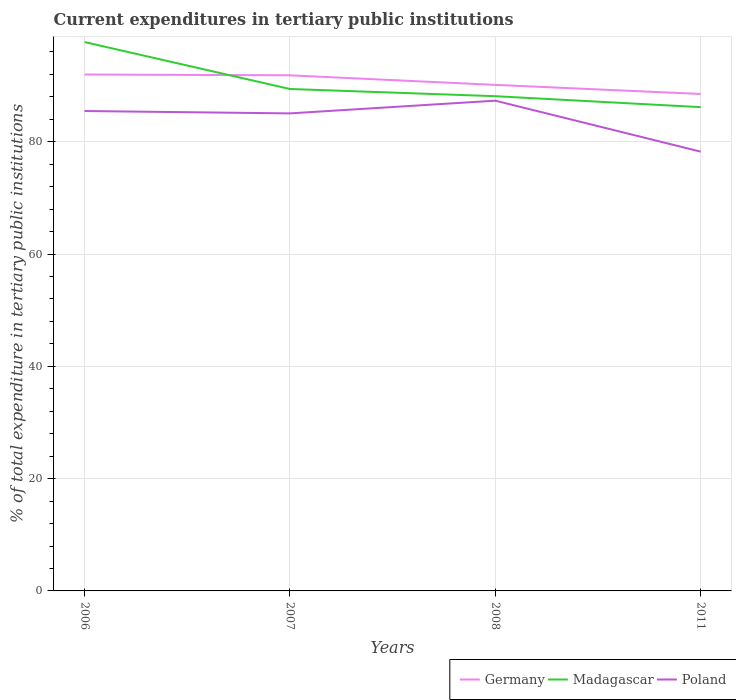How many different coloured lines are there?
Keep it short and to the point. 3. Does the line corresponding to Madagascar intersect with the line corresponding to Germany?
Offer a terse response. Yes. Is the number of lines equal to the number of legend labels?
Provide a short and direct response. Yes. Across all years, what is the maximum current expenditures in tertiary public institutions in Poland?
Your answer should be very brief. 78.23. In which year was the current expenditures in tertiary public institutions in Germany maximum?
Offer a terse response. 2011. What is the total current expenditures in tertiary public institutions in Poland in the graph?
Give a very brief answer. 7.24. What is the difference between the highest and the second highest current expenditures in tertiary public institutions in Madagascar?
Your answer should be compact. 11.59. What is the difference between the highest and the lowest current expenditures in tertiary public institutions in Poland?
Your answer should be very brief. 3. Are the values on the major ticks of Y-axis written in scientific E-notation?
Your answer should be compact. No. How many legend labels are there?
Provide a short and direct response. 3. How are the legend labels stacked?
Your answer should be very brief. Horizontal. What is the title of the graph?
Keep it short and to the point. Current expenditures in tertiary public institutions. What is the label or title of the Y-axis?
Keep it short and to the point. % of total expenditure in tertiary public institutions. What is the % of total expenditure in tertiary public institutions in Germany in 2006?
Make the answer very short. 91.97. What is the % of total expenditure in tertiary public institutions of Madagascar in 2006?
Give a very brief answer. 97.75. What is the % of total expenditure in tertiary public institutions in Poland in 2006?
Keep it short and to the point. 85.47. What is the % of total expenditure in tertiary public institutions in Germany in 2007?
Your response must be concise. 91.83. What is the % of total expenditure in tertiary public institutions of Madagascar in 2007?
Provide a succinct answer. 89.39. What is the % of total expenditure in tertiary public institutions in Poland in 2007?
Offer a terse response. 85.05. What is the % of total expenditure in tertiary public institutions in Germany in 2008?
Make the answer very short. 90.12. What is the % of total expenditure in tertiary public institutions in Madagascar in 2008?
Ensure brevity in your answer.  88.11. What is the % of total expenditure in tertiary public institutions in Poland in 2008?
Provide a short and direct response. 87.31. What is the % of total expenditure in tertiary public institutions in Germany in 2011?
Your response must be concise. 88.5. What is the % of total expenditure in tertiary public institutions in Madagascar in 2011?
Make the answer very short. 86.16. What is the % of total expenditure in tertiary public institutions of Poland in 2011?
Give a very brief answer. 78.23. Across all years, what is the maximum % of total expenditure in tertiary public institutions in Germany?
Your answer should be compact. 91.97. Across all years, what is the maximum % of total expenditure in tertiary public institutions in Madagascar?
Provide a short and direct response. 97.75. Across all years, what is the maximum % of total expenditure in tertiary public institutions in Poland?
Your answer should be very brief. 87.31. Across all years, what is the minimum % of total expenditure in tertiary public institutions in Germany?
Offer a very short reply. 88.5. Across all years, what is the minimum % of total expenditure in tertiary public institutions in Madagascar?
Keep it short and to the point. 86.16. Across all years, what is the minimum % of total expenditure in tertiary public institutions of Poland?
Your answer should be compact. 78.23. What is the total % of total expenditure in tertiary public institutions in Germany in the graph?
Your answer should be compact. 362.42. What is the total % of total expenditure in tertiary public institutions of Madagascar in the graph?
Give a very brief answer. 361.41. What is the total % of total expenditure in tertiary public institutions of Poland in the graph?
Your response must be concise. 336.06. What is the difference between the % of total expenditure in tertiary public institutions of Germany in 2006 and that in 2007?
Ensure brevity in your answer.  0.15. What is the difference between the % of total expenditure in tertiary public institutions of Madagascar in 2006 and that in 2007?
Give a very brief answer. 8.36. What is the difference between the % of total expenditure in tertiary public institutions in Poland in 2006 and that in 2007?
Ensure brevity in your answer.  0.42. What is the difference between the % of total expenditure in tertiary public institutions of Germany in 2006 and that in 2008?
Offer a terse response. 1.85. What is the difference between the % of total expenditure in tertiary public institutions of Madagascar in 2006 and that in 2008?
Offer a very short reply. 9.64. What is the difference between the % of total expenditure in tertiary public institutions in Poland in 2006 and that in 2008?
Your response must be concise. -1.84. What is the difference between the % of total expenditure in tertiary public institutions of Germany in 2006 and that in 2011?
Make the answer very short. 3.47. What is the difference between the % of total expenditure in tertiary public institutions in Madagascar in 2006 and that in 2011?
Provide a short and direct response. 11.59. What is the difference between the % of total expenditure in tertiary public institutions of Poland in 2006 and that in 2011?
Provide a short and direct response. 7.24. What is the difference between the % of total expenditure in tertiary public institutions in Germany in 2007 and that in 2008?
Keep it short and to the point. 1.7. What is the difference between the % of total expenditure in tertiary public institutions of Madagascar in 2007 and that in 2008?
Give a very brief answer. 1.28. What is the difference between the % of total expenditure in tertiary public institutions in Poland in 2007 and that in 2008?
Provide a succinct answer. -2.26. What is the difference between the % of total expenditure in tertiary public institutions of Germany in 2007 and that in 2011?
Ensure brevity in your answer.  3.32. What is the difference between the % of total expenditure in tertiary public institutions of Madagascar in 2007 and that in 2011?
Your answer should be very brief. 3.23. What is the difference between the % of total expenditure in tertiary public institutions of Poland in 2007 and that in 2011?
Keep it short and to the point. 6.81. What is the difference between the % of total expenditure in tertiary public institutions of Germany in 2008 and that in 2011?
Provide a short and direct response. 1.62. What is the difference between the % of total expenditure in tertiary public institutions of Madagascar in 2008 and that in 2011?
Give a very brief answer. 1.95. What is the difference between the % of total expenditure in tertiary public institutions of Poland in 2008 and that in 2011?
Keep it short and to the point. 9.08. What is the difference between the % of total expenditure in tertiary public institutions in Germany in 2006 and the % of total expenditure in tertiary public institutions in Madagascar in 2007?
Make the answer very short. 2.58. What is the difference between the % of total expenditure in tertiary public institutions of Germany in 2006 and the % of total expenditure in tertiary public institutions of Poland in 2007?
Your response must be concise. 6.93. What is the difference between the % of total expenditure in tertiary public institutions in Madagascar in 2006 and the % of total expenditure in tertiary public institutions in Poland in 2007?
Your response must be concise. 12.7. What is the difference between the % of total expenditure in tertiary public institutions in Germany in 2006 and the % of total expenditure in tertiary public institutions in Madagascar in 2008?
Offer a terse response. 3.87. What is the difference between the % of total expenditure in tertiary public institutions of Germany in 2006 and the % of total expenditure in tertiary public institutions of Poland in 2008?
Ensure brevity in your answer.  4.66. What is the difference between the % of total expenditure in tertiary public institutions of Madagascar in 2006 and the % of total expenditure in tertiary public institutions of Poland in 2008?
Your response must be concise. 10.44. What is the difference between the % of total expenditure in tertiary public institutions in Germany in 2006 and the % of total expenditure in tertiary public institutions in Madagascar in 2011?
Offer a very short reply. 5.82. What is the difference between the % of total expenditure in tertiary public institutions in Germany in 2006 and the % of total expenditure in tertiary public institutions in Poland in 2011?
Provide a succinct answer. 13.74. What is the difference between the % of total expenditure in tertiary public institutions in Madagascar in 2006 and the % of total expenditure in tertiary public institutions in Poland in 2011?
Provide a succinct answer. 19.52. What is the difference between the % of total expenditure in tertiary public institutions in Germany in 2007 and the % of total expenditure in tertiary public institutions in Madagascar in 2008?
Make the answer very short. 3.72. What is the difference between the % of total expenditure in tertiary public institutions of Germany in 2007 and the % of total expenditure in tertiary public institutions of Poland in 2008?
Make the answer very short. 4.51. What is the difference between the % of total expenditure in tertiary public institutions in Madagascar in 2007 and the % of total expenditure in tertiary public institutions in Poland in 2008?
Keep it short and to the point. 2.08. What is the difference between the % of total expenditure in tertiary public institutions in Germany in 2007 and the % of total expenditure in tertiary public institutions in Madagascar in 2011?
Your response must be concise. 5.67. What is the difference between the % of total expenditure in tertiary public institutions in Germany in 2007 and the % of total expenditure in tertiary public institutions in Poland in 2011?
Offer a very short reply. 13.59. What is the difference between the % of total expenditure in tertiary public institutions of Madagascar in 2007 and the % of total expenditure in tertiary public institutions of Poland in 2011?
Provide a short and direct response. 11.16. What is the difference between the % of total expenditure in tertiary public institutions of Germany in 2008 and the % of total expenditure in tertiary public institutions of Madagascar in 2011?
Make the answer very short. 3.96. What is the difference between the % of total expenditure in tertiary public institutions of Germany in 2008 and the % of total expenditure in tertiary public institutions of Poland in 2011?
Offer a terse response. 11.89. What is the difference between the % of total expenditure in tertiary public institutions of Madagascar in 2008 and the % of total expenditure in tertiary public institutions of Poland in 2011?
Provide a short and direct response. 9.88. What is the average % of total expenditure in tertiary public institutions in Germany per year?
Make the answer very short. 90.61. What is the average % of total expenditure in tertiary public institutions in Madagascar per year?
Offer a terse response. 90.35. What is the average % of total expenditure in tertiary public institutions of Poland per year?
Your response must be concise. 84.01. In the year 2006, what is the difference between the % of total expenditure in tertiary public institutions in Germany and % of total expenditure in tertiary public institutions in Madagascar?
Keep it short and to the point. -5.78. In the year 2006, what is the difference between the % of total expenditure in tertiary public institutions of Germany and % of total expenditure in tertiary public institutions of Poland?
Your answer should be very brief. 6.5. In the year 2006, what is the difference between the % of total expenditure in tertiary public institutions in Madagascar and % of total expenditure in tertiary public institutions in Poland?
Make the answer very short. 12.28. In the year 2007, what is the difference between the % of total expenditure in tertiary public institutions in Germany and % of total expenditure in tertiary public institutions in Madagascar?
Offer a very short reply. 2.43. In the year 2007, what is the difference between the % of total expenditure in tertiary public institutions in Germany and % of total expenditure in tertiary public institutions in Poland?
Offer a very short reply. 6.78. In the year 2007, what is the difference between the % of total expenditure in tertiary public institutions of Madagascar and % of total expenditure in tertiary public institutions of Poland?
Make the answer very short. 4.34. In the year 2008, what is the difference between the % of total expenditure in tertiary public institutions in Germany and % of total expenditure in tertiary public institutions in Madagascar?
Your answer should be very brief. 2.01. In the year 2008, what is the difference between the % of total expenditure in tertiary public institutions of Germany and % of total expenditure in tertiary public institutions of Poland?
Your response must be concise. 2.81. In the year 2008, what is the difference between the % of total expenditure in tertiary public institutions of Madagascar and % of total expenditure in tertiary public institutions of Poland?
Your answer should be compact. 0.8. In the year 2011, what is the difference between the % of total expenditure in tertiary public institutions of Germany and % of total expenditure in tertiary public institutions of Madagascar?
Provide a short and direct response. 2.35. In the year 2011, what is the difference between the % of total expenditure in tertiary public institutions in Germany and % of total expenditure in tertiary public institutions in Poland?
Give a very brief answer. 10.27. In the year 2011, what is the difference between the % of total expenditure in tertiary public institutions of Madagascar and % of total expenditure in tertiary public institutions of Poland?
Offer a terse response. 7.93. What is the ratio of the % of total expenditure in tertiary public institutions of Madagascar in 2006 to that in 2007?
Provide a succinct answer. 1.09. What is the ratio of the % of total expenditure in tertiary public institutions of Poland in 2006 to that in 2007?
Your answer should be very brief. 1. What is the ratio of the % of total expenditure in tertiary public institutions in Germany in 2006 to that in 2008?
Your answer should be very brief. 1.02. What is the ratio of the % of total expenditure in tertiary public institutions in Madagascar in 2006 to that in 2008?
Ensure brevity in your answer.  1.11. What is the ratio of the % of total expenditure in tertiary public institutions of Poland in 2006 to that in 2008?
Your answer should be very brief. 0.98. What is the ratio of the % of total expenditure in tertiary public institutions of Germany in 2006 to that in 2011?
Provide a succinct answer. 1.04. What is the ratio of the % of total expenditure in tertiary public institutions in Madagascar in 2006 to that in 2011?
Offer a terse response. 1.13. What is the ratio of the % of total expenditure in tertiary public institutions of Poland in 2006 to that in 2011?
Offer a very short reply. 1.09. What is the ratio of the % of total expenditure in tertiary public institutions in Germany in 2007 to that in 2008?
Give a very brief answer. 1.02. What is the ratio of the % of total expenditure in tertiary public institutions in Madagascar in 2007 to that in 2008?
Your answer should be very brief. 1.01. What is the ratio of the % of total expenditure in tertiary public institutions of Poland in 2007 to that in 2008?
Your response must be concise. 0.97. What is the ratio of the % of total expenditure in tertiary public institutions in Germany in 2007 to that in 2011?
Make the answer very short. 1.04. What is the ratio of the % of total expenditure in tertiary public institutions in Madagascar in 2007 to that in 2011?
Your answer should be compact. 1.04. What is the ratio of the % of total expenditure in tertiary public institutions in Poland in 2007 to that in 2011?
Your answer should be compact. 1.09. What is the ratio of the % of total expenditure in tertiary public institutions in Germany in 2008 to that in 2011?
Make the answer very short. 1.02. What is the ratio of the % of total expenditure in tertiary public institutions in Madagascar in 2008 to that in 2011?
Your answer should be very brief. 1.02. What is the ratio of the % of total expenditure in tertiary public institutions in Poland in 2008 to that in 2011?
Your response must be concise. 1.12. What is the difference between the highest and the second highest % of total expenditure in tertiary public institutions of Germany?
Keep it short and to the point. 0.15. What is the difference between the highest and the second highest % of total expenditure in tertiary public institutions in Madagascar?
Your response must be concise. 8.36. What is the difference between the highest and the second highest % of total expenditure in tertiary public institutions in Poland?
Make the answer very short. 1.84. What is the difference between the highest and the lowest % of total expenditure in tertiary public institutions in Germany?
Ensure brevity in your answer.  3.47. What is the difference between the highest and the lowest % of total expenditure in tertiary public institutions of Madagascar?
Give a very brief answer. 11.59. What is the difference between the highest and the lowest % of total expenditure in tertiary public institutions in Poland?
Make the answer very short. 9.08. 